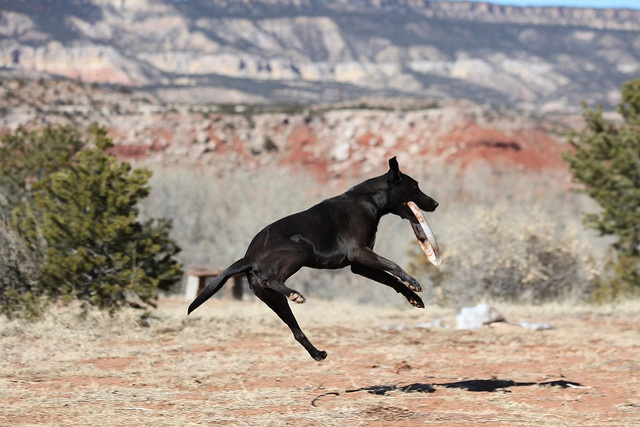Describe the objects in this image and their specific colors. I can see dog in gray, black, and darkgray tones, bench in gray, darkgray, black, and lightgray tones, and frisbee in gray, darkgray, lightgray, and tan tones in this image. 